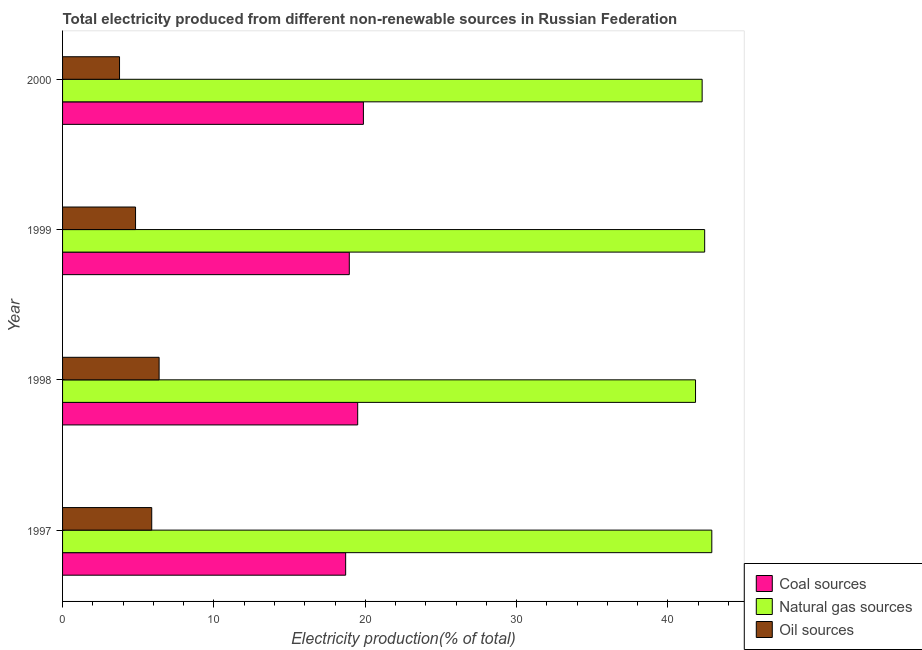How many different coloured bars are there?
Offer a very short reply. 3. How many groups of bars are there?
Keep it short and to the point. 4. Are the number of bars per tick equal to the number of legend labels?
Keep it short and to the point. Yes. Are the number of bars on each tick of the Y-axis equal?
Keep it short and to the point. Yes. How many bars are there on the 2nd tick from the top?
Offer a very short reply. 3. What is the label of the 1st group of bars from the top?
Your answer should be compact. 2000. In how many cases, is the number of bars for a given year not equal to the number of legend labels?
Offer a very short reply. 0. What is the percentage of electricity produced by coal in 1998?
Provide a short and direct response. 19.5. Across all years, what is the maximum percentage of electricity produced by natural gas?
Your answer should be compact. 42.9. Across all years, what is the minimum percentage of electricity produced by coal?
Your response must be concise. 18.7. In which year was the percentage of electricity produced by natural gas minimum?
Offer a terse response. 1998. What is the total percentage of electricity produced by natural gas in the graph?
Your response must be concise. 169.4. What is the difference between the percentage of electricity produced by oil sources in 1998 and that in 2000?
Your answer should be compact. 2.62. What is the difference between the percentage of electricity produced by natural gas in 1998 and the percentage of electricity produced by oil sources in 1999?
Provide a succinct answer. 37. What is the average percentage of electricity produced by coal per year?
Your answer should be very brief. 19.26. In the year 1998, what is the difference between the percentage of electricity produced by natural gas and percentage of electricity produced by coal?
Your response must be concise. 22.32. In how many years, is the percentage of electricity produced by natural gas greater than 6 %?
Offer a terse response. 4. What is the ratio of the percentage of electricity produced by oil sources in 1998 to that in 1999?
Give a very brief answer. 1.32. Is the difference between the percentage of electricity produced by natural gas in 1998 and 2000 greater than the difference between the percentage of electricity produced by coal in 1998 and 2000?
Provide a succinct answer. No. What is the difference between the highest and the second highest percentage of electricity produced by natural gas?
Offer a very short reply. 0.47. What is the difference between the highest and the lowest percentage of electricity produced by coal?
Provide a succinct answer. 1.17. Is the sum of the percentage of electricity produced by oil sources in 1999 and 2000 greater than the maximum percentage of electricity produced by coal across all years?
Provide a succinct answer. No. What does the 1st bar from the top in 1998 represents?
Your response must be concise. Oil sources. What does the 2nd bar from the bottom in 1999 represents?
Provide a succinct answer. Natural gas sources. What is the difference between two consecutive major ticks on the X-axis?
Provide a succinct answer. 10. Does the graph contain any zero values?
Your answer should be compact. No. Where does the legend appear in the graph?
Keep it short and to the point. Bottom right. How many legend labels are there?
Your response must be concise. 3. What is the title of the graph?
Keep it short and to the point. Total electricity produced from different non-renewable sources in Russian Federation. What is the label or title of the X-axis?
Ensure brevity in your answer.  Electricity production(% of total). What is the Electricity production(% of total) of Coal sources in 1997?
Your answer should be very brief. 18.7. What is the Electricity production(% of total) of Natural gas sources in 1997?
Keep it short and to the point. 42.9. What is the Electricity production(% of total) of Oil sources in 1997?
Make the answer very short. 5.89. What is the Electricity production(% of total) in Coal sources in 1998?
Your answer should be compact. 19.5. What is the Electricity production(% of total) of Natural gas sources in 1998?
Offer a very short reply. 41.82. What is the Electricity production(% of total) of Oil sources in 1998?
Your answer should be very brief. 6.38. What is the Electricity production(% of total) of Coal sources in 1999?
Provide a short and direct response. 18.94. What is the Electricity production(% of total) in Natural gas sources in 1999?
Provide a short and direct response. 42.42. What is the Electricity production(% of total) of Oil sources in 1999?
Make the answer very short. 4.82. What is the Electricity production(% of total) in Coal sources in 2000?
Your answer should be compact. 19.88. What is the Electricity production(% of total) of Natural gas sources in 2000?
Offer a terse response. 42.26. What is the Electricity production(% of total) in Oil sources in 2000?
Provide a succinct answer. 3.76. Across all years, what is the maximum Electricity production(% of total) of Coal sources?
Your answer should be very brief. 19.88. Across all years, what is the maximum Electricity production(% of total) of Natural gas sources?
Your response must be concise. 42.9. Across all years, what is the maximum Electricity production(% of total) of Oil sources?
Offer a very short reply. 6.38. Across all years, what is the minimum Electricity production(% of total) of Coal sources?
Offer a terse response. 18.7. Across all years, what is the minimum Electricity production(% of total) of Natural gas sources?
Offer a terse response. 41.82. Across all years, what is the minimum Electricity production(% of total) in Oil sources?
Ensure brevity in your answer.  3.76. What is the total Electricity production(% of total) in Coal sources in the graph?
Your answer should be compact. 77.03. What is the total Electricity production(% of total) of Natural gas sources in the graph?
Provide a short and direct response. 169.4. What is the total Electricity production(% of total) in Oil sources in the graph?
Keep it short and to the point. 20.86. What is the difference between the Electricity production(% of total) of Coal sources in 1997 and that in 1998?
Offer a terse response. -0.79. What is the difference between the Electricity production(% of total) of Natural gas sources in 1997 and that in 1998?
Offer a very short reply. 1.08. What is the difference between the Electricity production(% of total) in Oil sources in 1997 and that in 1998?
Your answer should be compact. -0.49. What is the difference between the Electricity production(% of total) of Coal sources in 1997 and that in 1999?
Offer a terse response. -0.24. What is the difference between the Electricity production(% of total) of Natural gas sources in 1997 and that in 1999?
Offer a terse response. 0.47. What is the difference between the Electricity production(% of total) of Oil sources in 1997 and that in 1999?
Your response must be concise. 1.07. What is the difference between the Electricity production(% of total) of Coal sources in 1997 and that in 2000?
Provide a succinct answer. -1.17. What is the difference between the Electricity production(% of total) of Natural gas sources in 1997 and that in 2000?
Offer a terse response. 0.64. What is the difference between the Electricity production(% of total) in Oil sources in 1997 and that in 2000?
Provide a succinct answer. 2.13. What is the difference between the Electricity production(% of total) of Coal sources in 1998 and that in 1999?
Your answer should be compact. 0.55. What is the difference between the Electricity production(% of total) in Natural gas sources in 1998 and that in 1999?
Keep it short and to the point. -0.6. What is the difference between the Electricity production(% of total) of Oil sources in 1998 and that in 1999?
Your answer should be compact. 1.56. What is the difference between the Electricity production(% of total) of Coal sources in 1998 and that in 2000?
Ensure brevity in your answer.  -0.38. What is the difference between the Electricity production(% of total) of Natural gas sources in 1998 and that in 2000?
Offer a terse response. -0.44. What is the difference between the Electricity production(% of total) of Oil sources in 1998 and that in 2000?
Your response must be concise. 2.61. What is the difference between the Electricity production(% of total) of Coal sources in 1999 and that in 2000?
Keep it short and to the point. -0.93. What is the difference between the Electricity production(% of total) of Natural gas sources in 1999 and that in 2000?
Your answer should be compact. 0.17. What is the difference between the Electricity production(% of total) in Oil sources in 1999 and that in 2000?
Ensure brevity in your answer.  1.06. What is the difference between the Electricity production(% of total) of Coal sources in 1997 and the Electricity production(% of total) of Natural gas sources in 1998?
Offer a very short reply. -23.12. What is the difference between the Electricity production(% of total) in Coal sources in 1997 and the Electricity production(% of total) in Oil sources in 1998?
Your answer should be very brief. 12.33. What is the difference between the Electricity production(% of total) in Natural gas sources in 1997 and the Electricity production(% of total) in Oil sources in 1998?
Your response must be concise. 36.52. What is the difference between the Electricity production(% of total) of Coal sources in 1997 and the Electricity production(% of total) of Natural gas sources in 1999?
Offer a terse response. -23.72. What is the difference between the Electricity production(% of total) in Coal sources in 1997 and the Electricity production(% of total) in Oil sources in 1999?
Provide a short and direct response. 13.88. What is the difference between the Electricity production(% of total) in Natural gas sources in 1997 and the Electricity production(% of total) in Oil sources in 1999?
Offer a terse response. 38.07. What is the difference between the Electricity production(% of total) in Coal sources in 1997 and the Electricity production(% of total) in Natural gas sources in 2000?
Provide a succinct answer. -23.55. What is the difference between the Electricity production(% of total) of Coal sources in 1997 and the Electricity production(% of total) of Oil sources in 2000?
Keep it short and to the point. 14.94. What is the difference between the Electricity production(% of total) of Natural gas sources in 1997 and the Electricity production(% of total) of Oil sources in 2000?
Offer a very short reply. 39.13. What is the difference between the Electricity production(% of total) in Coal sources in 1998 and the Electricity production(% of total) in Natural gas sources in 1999?
Provide a short and direct response. -22.93. What is the difference between the Electricity production(% of total) of Coal sources in 1998 and the Electricity production(% of total) of Oil sources in 1999?
Offer a terse response. 14.68. What is the difference between the Electricity production(% of total) of Natural gas sources in 1998 and the Electricity production(% of total) of Oil sources in 1999?
Make the answer very short. 37. What is the difference between the Electricity production(% of total) in Coal sources in 1998 and the Electricity production(% of total) in Natural gas sources in 2000?
Keep it short and to the point. -22.76. What is the difference between the Electricity production(% of total) in Coal sources in 1998 and the Electricity production(% of total) in Oil sources in 2000?
Your answer should be compact. 15.74. What is the difference between the Electricity production(% of total) in Natural gas sources in 1998 and the Electricity production(% of total) in Oil sources in 2000?
Give a very brief answer. 38.06. What is the difference between the Electricity production(% of total) of Coal sources in 1999 and the Electricity production(% of total) of Natural gas sources in 2000?
Offer a very short reply. -23.31. What is the difference between the Electricity production(% of total) of Coal sources in 1999 and the Electricity production(% of total) of Oil sources in 2000?
Give a very brief answer. 15.18. What is the difference between the Electricity production(% of total) of Natural gas sources in 1999 and the Electricity production(% of total) of Oil sources in 2000?
Keep it short and to the point. 38.66. What is the average Electricity production(% of total) in Coal sources per year?
Make the answer very short. 19.26. What is the average Electricity production(% of total) of Natural gas sources per year?
Keep it short and to the point. 42.35. What is the average Electricity production(% of total) in Oil sources per year?
Offer a terse response. 5.21. In the year 1997, what is the difference between the Electricity production(% of total) of Coal sources and Electricity production(% of total) of Natural gas sources?
Provide a short and direct response. -24.19. In the year 1997, what is the difference between the Electricity production(% of total) in Coal sources and Electricity production(% of total) in Oil sources?
Keep it short and to the point. 12.81. In the year 1997, what is the difference between the Electricity production(% of total) of Natural gas sources and Electricity production(% of total) of Oil sources?
Your response must be concise. 37. In the year 1998, what is the difference between the Electricity production(% of total) of Coal sources and Electricity production(% of total) of Natural gas sources?
Make the answer very short. -22.32. In the year 1998, what is the difference between the Electricity production(% of total) of Coal sources and Electricity production(% of total) of Oil sources?
Make the answer very short. 13.12. In the year 1998, what is the difference between the Electricity production(% of total) of Natural gas sources and Electricity production(% of total) of Oil sources?
Your answer should be very brief. 35.44. In the year 1999, what is the difference between the Electricity production(% of total) of Coal sources and Electricity production(% of total) of Natural gas sources?
Keep it short and to the point. -23.48. In the year 1999, what is the difference between the Electricity production(% of total) of Coal sources and Electricity production(% of total) of Oil sources?
Your response must be concise. 14.12. In the year 1999, what is the difference between the Electricity production(% of total) of Natural gas sources and Electricity production(% of total) of Oil sources?
Give a very brief answer. 37.6. In the year 2000, what is the difference between the Electricity production(% of total) in Coal sources and Electricity production(% of total) in Natural gas sources?
Your response must be concise. -22.38. In the year 2000, what is the difference between the Electricity production(% of total) of Coal sources and Electricity production(% of total) of Oil sources?
Give a very brief answer. 16.11. In the year 2000, what is the difference between the Electricity production(% of total) in Natural gas sources and Electricity production(% of total) in Oil sources?
Your response must be concise. 38.49. What is the ratio of the Electricity production(% of total) of Coal sources in 1997 to that in 1998?
Keep it short and to the point. 0.96. What is the ratio of the Electricity production(% of total) of Natural gas sources in 1997 to that in 1998?
Your answer should be very brief. 1.03. What is the ratio of the Electricity production(% of total) in Oil sources in 1997 to that in 1998?
Provide a short and direct response. 0.92. What is the ratio of the Electricity production(% of total) of Coal sources in 1997 to that in 1999?
Offer a very short reply. 0.99. What is the ratio of the Electricity production(% of total) in Natural gas sources in 1997 to that in 1999?
Make the answer very short. 1.01. What is the ratio of the Electricity production(% of total) of Oil sources in 1997 to that in 1999?
Provide a succinct answer. 1.22. What is the ratio of the Electricity production(% of total) of Coal sources in 1997 to that in 2000?
Make the answer very short. 0.94. What is the ratio of the Electricity production(% of total) of Natural gas sources in 1997 to that in 2000?
Your answer should be very brief. 1.02. What is the ratio of the Electricity production(% of total) in Oil sources in 1997 to that in 2000?
Your answer should be very brief. 1.57. What is the ratio of the Electricity production(% of total) of Coal sources in 1998 to that in 1999?
Your response must be concise. 1.03. What is the ratio of the Electricity production(% of total) of Natural gas sources in 1998 to that in 1999?
Offer a terse response. 0.99. What is the ratio of the Electricity production(% of total) in Oil sources in 1998 to that in 1999?
Offer a very short reply. 1.32. What is the ratio of the Electricity production(% of total) in Natural gas sources in 1998 to that in 2000?
Give a very brief answer. 0.99. What is the ratio of the Electricity production(% of total) of Oil sources in 1998 to that in 2000?
Keep it short and to the point. 1.69. What is the ratio of the Electricity production(% of total) in Coal sources in 1999 to that in 2000?
Keep it short and to the point. 0.95. What is the ratio of the Electricity production(% of total) of Natural gas sources in 1999 to that in 2000?
Make the answer very short. 1. What is the ratio of the Electricity production(% of total) of Oil sources in 1999 to that in 2000?
Your answer should be compact. 1.28. What is the difference between the highest and the second highest Electricity production(% of total) of Coal sources?
Your answer should be compact. 0.38. What is the difference between the highest and the second highest Electricity production(% of total) in Natural gas sources?
Keep it short and to the point. 0.47. What is the difference between the highest and the second highest Electricity production(% of total) of Oil sources?
Give a very brief answer. 0.49. What is the difference between the highest and the lowest Electricity production(% of total) of Coal sources?
Provide a short and direct response. 1.17. What is the difference between the highest and the lowest Electricity production(% of total) of Natural gas sources?
Offer a terse response. 1.08. What is the difference between the highest and the lowest Electricity production(% of total) of Oil sources?
Provide a short and direct response. 2.61. 